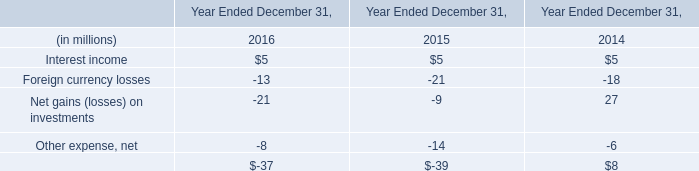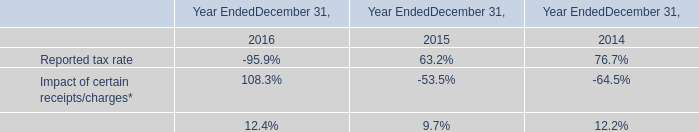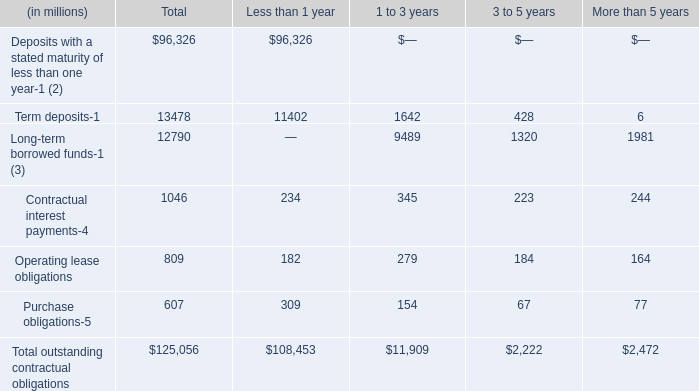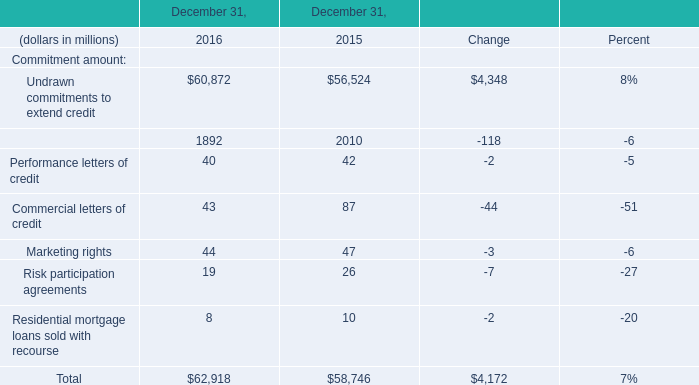In the year/section with the most Undrawn commitments to extend credit, what is the growth rate of Financial standby letters of credit? 
Computations: ((1892 - 2010) / 2010)
Answer: -0.05871. 